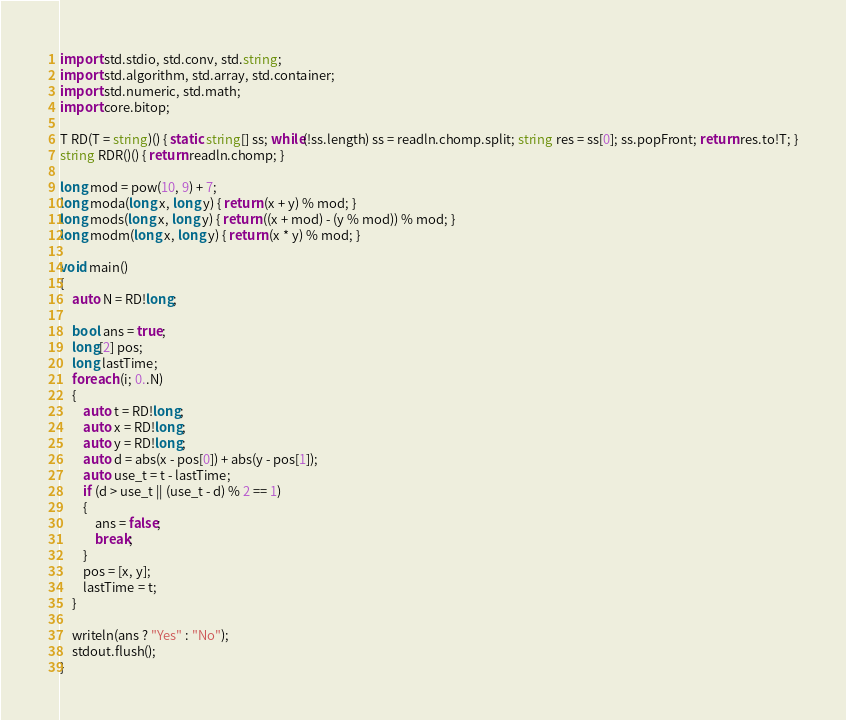<code> <loc_0><loc_0><loc_500><loc_500><_D_>import std.stdio, std.conv, std.string;
import std.algorithm, std.array, std.container;
import std.numeric, std.math;
import core.bitop;

T RD(T = string)() { static string[] ss; while(!ss.length) ss = readln.chomp.split; string res = ss[0]; ss.popFront; return res.to!T; }
string RDR()() { return readln.chomp; }

long mod = pow(10, 9) + 7;
long moda(long x, long y) { return (x + y) % mod; }
long mods(long x, long y) { return ((x + mod) - (y % mod)) % mod; }
long modm(long x, long y) { return (x * y) % mod; }

void main()
{
	auto N = RD!long;

	bool ans = true;
	long[2] pos;
	long lastTime;
	foreach (i; 0..N)
	{
		auto t = RD!long;
		auto x = RD!long;
		auto y = RD!long;
		auto d = abs(x - pos[0]) + abs(y - pos[1]);
		auto use_t = t - lastTime;
		if (d > use_t || (use_t - d) % 2 == 1)
		{
			ans = false;
			break;
		}
		pos = [x, y];
		lastTime = t;
	}

	writeln(ans ? "Yes" : "No");
	stdout.flush();
}</code> 